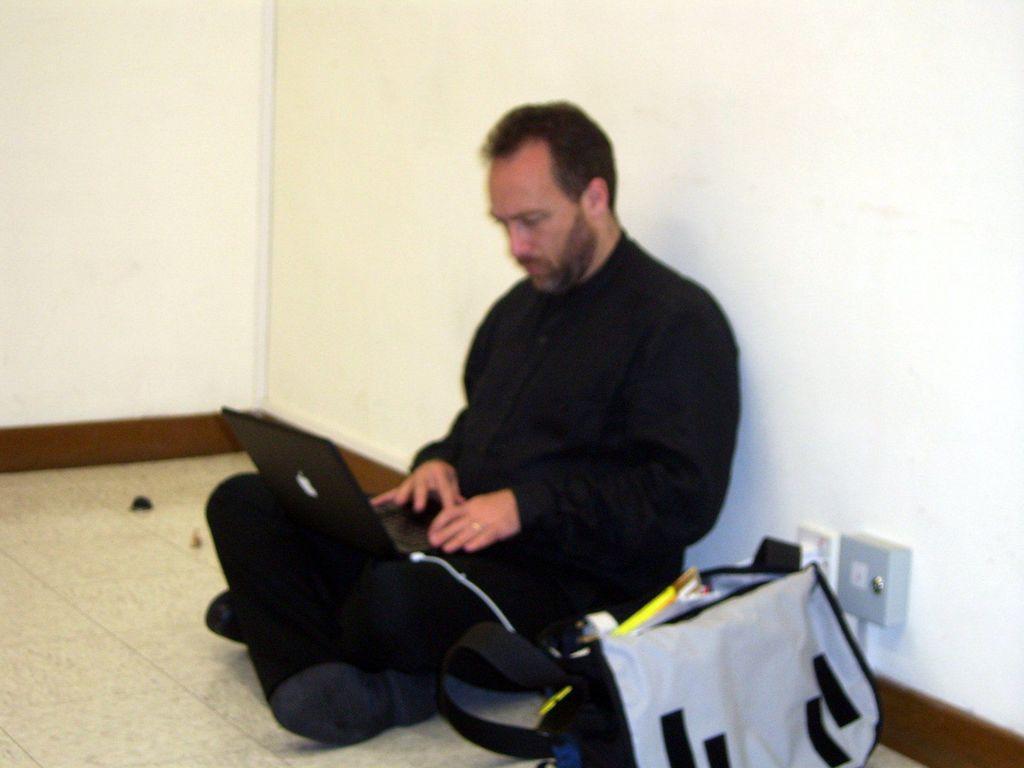Could you give a brief overview of what you see in this image? In the foreground, I can see a person is sitting on the floor, is holding a laptop in hand and I can see a bag on the floor. In the background, I can see a wall. This picture might be taken in a hall. 